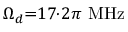Convert formula to latex. <formula><loc_0><loc_0><loc_500><loc_500>\Omega _ { d } { = } 1 7 { \cdot } 2 \pi \ M H z</formula> 